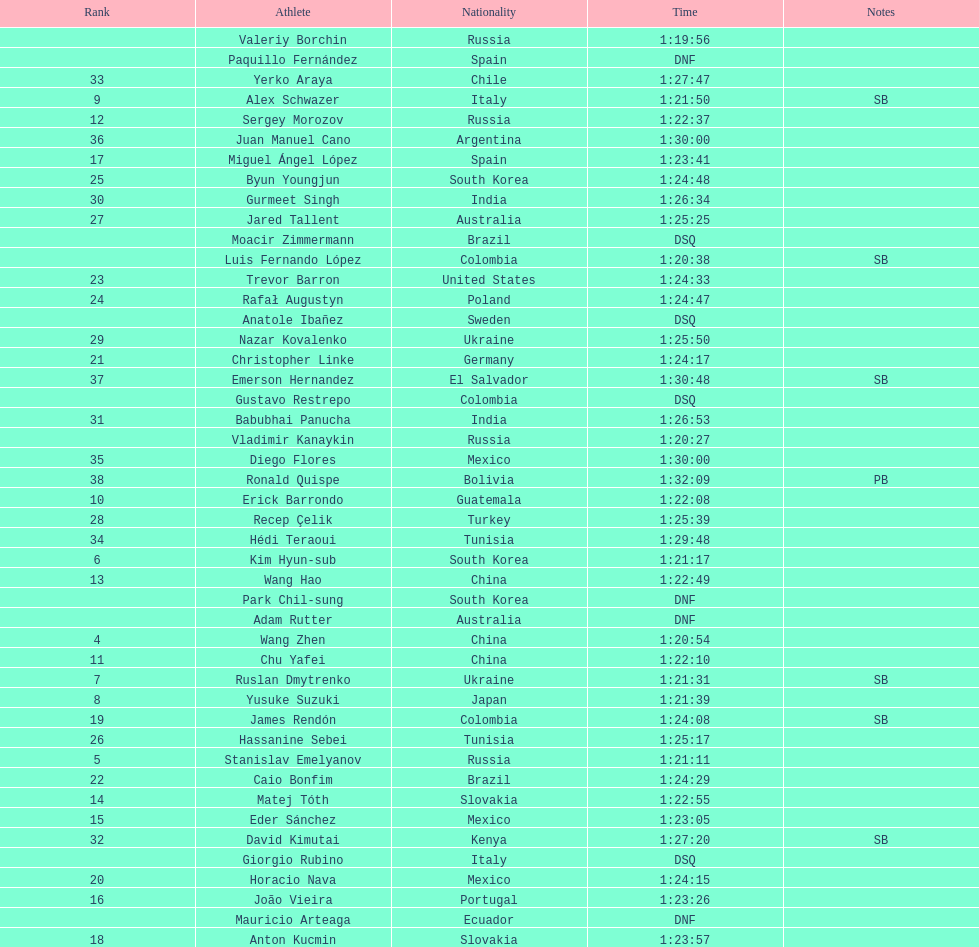Wang zhen and wang hao were both from which country? China. 